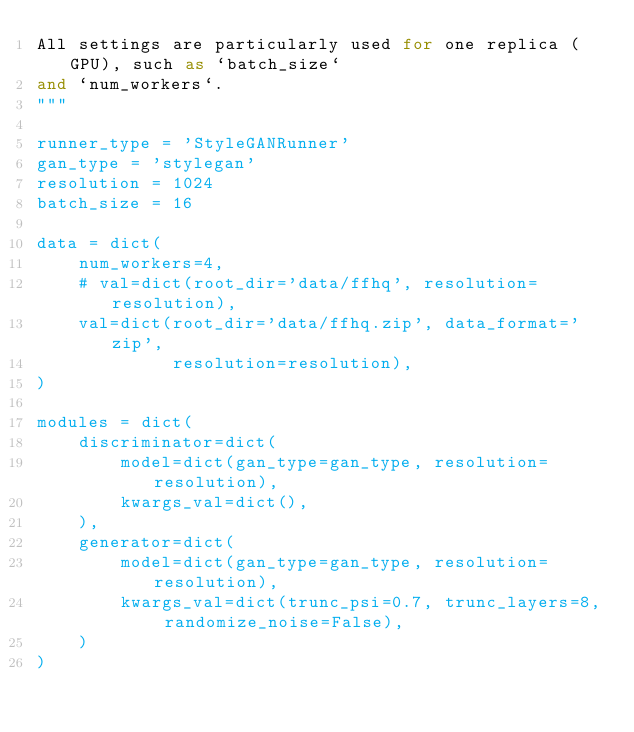Convert code to text. <code><loc_0><loc_0><loc_500><loc_500><_Python_>All settings are particularly used for one replica (GPU), such as `batch_size`
and `num_workers`.
"""

runner_type = 'StyleGANRunner'
gan_type = 'stylegan'
resolution = 1024
batch_size = 16

data = dict(
    num_workers=4,
    # val=dict(root_dir='data/ffhq', resolution=resolution),
    val=dict(root_dir='data/ffhq.zip', data_format='zip',
             resolution=resolution),
)

modules = dict(
    discriminator=dict(
        model=dict(gan_type=gan_type, resolution=resolution),
        kwargs_val=dict(),
    ),
    generator=dict(
        model=dict(gan_type=gan_type, resolution=resolution),
        kwargs_val=dict(trunc_psi=0.7, trunc_layers=8, randomize_noise=False),
    )
)
</code> 